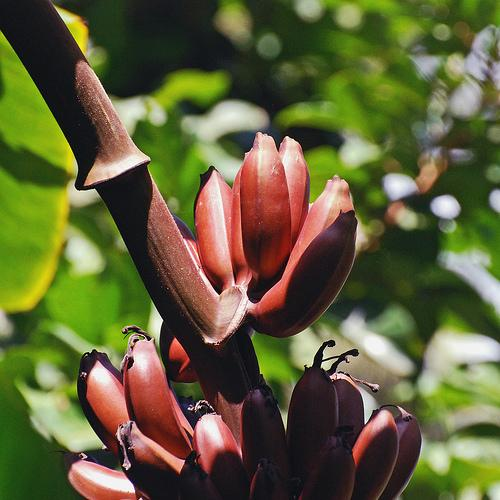Describe the subject of the image and what is happening in the scene. Red bananas are growing on a branch, surrounded by green leaves and sunlight, creating a lively outdoor setting. Provide a concise summary of the main object in the image and its surroundings. The image showcases red bananas on a tree branch, with a forest green background and sunlight filtering through. What is the prominent feature of the image in terms of the object and lighting? The red bananas are the highlight of the image, with sunlight shining on them and reflecting on the surrounding leaves. Elaborate on the most significant aspect of this image along with its context. A cluster of red bananas stands out on a tree branch, receiving sunlight and contrasting with the green leaves in the background. Mention the main components of the image and the environment they are in. Red bananas, brown plant stem, green leaves, and sunlight are present outdoors against a forest background. Provide a brief description of the primary object in the image. A bunch of small red bananas are growing on a brown tree branch. Illustrate the overall visual scene captured in this image. The picture shows red bananas growing on a branch, with a brown stem and green leaves in the blurry forest background. Describe the main colors and elements of the image. This image features red bananas on a brown stem, with green leaves and a sunlit forest backdrop. Explain the image's key subject and its interactions with the environment. Red bananas growing on a brown branch receive sunlight and are surrounded by green leaves, creating a vibrant outdoor scene. Express what the focal point of the image is and the surrounding elements. The central focus is on the red bananas thriving on a tree branch, complemented by the brown stem and green leaves. 